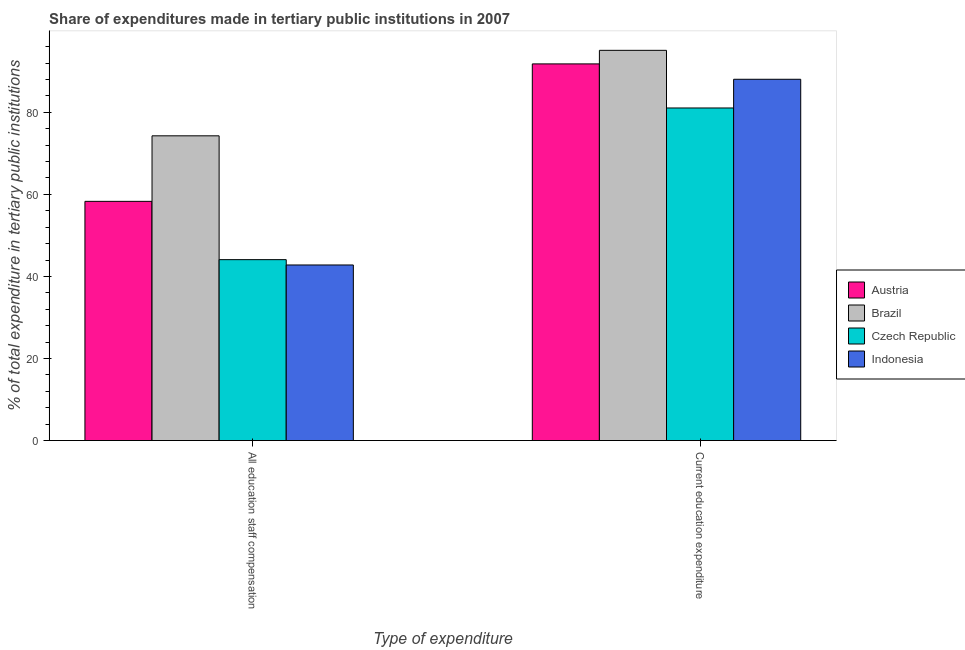Are the number of bars on each tick of the X-axis equal?
Make the answer very short. Yes. What is the label of the 2nd group of bars from the left?
Your answer should be compact. Current education expenditure. What is the expenditure in education in Indonesia?
Give a very brief answer. 88.04. Across all countries, what is the maximum expenditure in staff compensation?
Your answer should be very brief. 74.26. Across all countries, what is the minimum expenditure in education?
Your answer should be very brief. 81.05. In which country was the expenditure in education maximum?
Provide a succinct answer. Brazil. In which country was the expenditure in education minimum?
Make the answer very short. Czech Republic. What is the total expenditure in staff compensation in the graph?
Offer a terse response. 219.44. What is the difference between the expenditure in education in Czech Republic and that in Indonesia?
Keep it short and to the point. -7. What is the difference between the expenditure in education in Indonesia and the expenditure in staff compensation in Czech Republic?
Give a very brief answer. 43.96. What is the average expenditure in staff compensation per country?
Your answer should be very brief. 54.86. What is the difference between the expenditure in staff compensation and expenditure in education in Czech Republic?
Your answer should be very brief. -36.96. What is the ratio of the expenditure in staff compensation in Austria to that in Czech Republic?
Give a very brief answer. 1.32. What does the 4th bar from the left in All education staff compensation represents?
Your answer should be very brief. Indonesia. How many bars are there?
Your answer should be compact. 8. Are all the bars in the graph horizontal?
Your answer should be very brief. No. How many countries are there in the graph?
Make the answer very short. 4. Does the graph contain any zero values?
Provide a succinct answer. No. How many legend labels are there?
Provide a short and direct response. 4. What is the title of the graph?
Your answer should be very brief. Share of expenditures made in tertiary public institutions in 2007. Does "Least developed countries" appear as one of the legend labels in the graph?
Ensure brevity in your answer.  No. What is the label or title of the X-axis?
Offer a very short reply. Type of expenditure. What is the label or title of the Y-axis?
Give a very brief answer. % of total expenditure in tertiary public institutions. What is the % of total expenditure in tertiary public institutions of Austria in All education staff compensation?
Provide a short and direct response. 58.29. What is the % of total expenditure in tertiary public institutions in Brazil in All education staff compensation?
Keep it short and to the point. 74.26. What is the % of total expenditure in tertiary public institutions of Czech Republic in All education staff compensation?
Your answer should be compact. 44.09. What is the % of total expenditure in tertiary public institutions of Indonesia in All education staff compensation?
Your answer should be very brief. 42.79. What is the % of total expenditure in tertiary public institutions in Austria in Current education expenditure?
Offer a very short reply. 91.79. What is the % of total expenditure in tertiary public institutions in Brazil in Current education expenditure?
Offer a terse response. 95.09. What is the % of total expenditure in tertiary public institutions of Czech Republic in Current education expenditure?
Ensure brevity in your answer.  81.05. What is the % of total expenditure in tertiary public institutions in Indonesia in Current education expenditure?
Your answer should be very brief. 88.04. Across all Type of expenditure, what is the maximum % of total expenditure in tertiary public institutions in Austria?
Provide a succinct answer. 91.79. Across all Type of expenditure, what is the maximum % of total expenditure in tertiary public institutions in Brazil?
Your answer should be very brief. 95.09. Across all Type of expenditure, what is the maximum % of total expenditure in tertiary public institutions of Czech Republic?
Provide a succinct answer. 81.05. Across all Type of expenditure, what is the maximum % of total expenditure in tertiary public institutions in Indonesia?
Provide a short and direct response. 88.04. Across all Type of expenditure, what is the minimum % of total expenditure in tertiary public institutions in Austria?
Make the answer very short. 58.29. Across all Type of expenditure, what is the minimum % of total expenditure in tertiary public institutions in Brazil?
Your response must be concise. 74.26. Across all Type of expenditure, what is the minimum % of total expenditure in tertiary public institutions in Czech Republic?
Your answer should be very brief. 44.09. Across all Type of expenditure, what is the minimum % of total expenditure in tertiary public institutions of Indonesia?
Give a very brief answer. 42.79. What is the total % of total expenditure in tertiary public institutions in Austria in the graph?
Your answer should be very brief. 150.08. What is the total % of total expenditure in tertiary public institutions of Brazil in the graph?
Give a very brief answer. 169.36. What is the total % of total expenditure in tertiary public institutions of Czech Republic in the graph?
Offer a terse response. 125.14. What is the total % of total expenditure in tertiary public institutions of Indonesia in the graph?
Your answer should be very brief. 130.83. What is the difference between the % of total expenditure in tertiary public institutions of Austria in All education staff compensation and that in Current education expenditure?
Your response must be concise. -33.49. What is the difference between the % of total expenditure in tertiary public institutions of Brazil in All education staff compensation and that in Current education expenditure?
Give a very brief answer. -20.83. What is the difference between the % of total expenditure in tertiary public institutions of Czech Republic in All education staff compensation and that in Current education expenditure?
Ensure brevity in your answer.  -36.96. What is the difference between the % of total expenditure in tertiary public institutions in Indonesia in All education staff compensation and that in Current education expenditure?
Provide a short and direct response. -45.25. What is the difference between the % of total expenditure in tertiary public institutions in Austria in All education staff compensation and the % of total expenditure in tertiary public institutions in Brazil in Current education expenditure?
Make the answer very short. -36.8. What is the difference between the % of total expenditure in tertiary public institutions in Austria in All education staff compensation and the % of total expenditure in tertiary public institutions in Czech Republic in Current education expenditure?
Your response must be concise. -22.75. What is the difference between the % of total expenditure in tertiary public institutions of Austria in All education staff compensation and the % of total expenditure in tertiary public institutions of Indonesia in Current education expenditure?
Offer a terse response. -29.75. What is the difference between the % of total expenditure in tertiary public institutions in Brazil in All education staff compensation and the % of total expenditure in tertiary public institutions in Czech Republic in Current education expenditure?
Your response must be concise. -6.78. What is the difference between the % of total expenditure in tertiary public institutions of Brazil in All education staff compensation and the % of total expenditure in tertiary public institutions of Indonesia in Current education expenditure?
Your response must be concise. -13.78. What is the difference between the % of total expenditure in tertiary public institutions of Czech Republic in All education staff compensation and the % of total expenditure in tertiary public institutions of Indonesia in Current education expenditure?
Provide a succinct answer. -43.96. What is the average % of total expenditure in tertiary public institutions in Austria per Type of expenditure?
Your response must be concise. 75.04. What is the average % of total expenditure in tertiary public institutions of Brazil per Type of expenditure?
Your answer should be very brief. 84.68. What is the average % of total expenditure in tertiary public institutions in Czech Republic per Type of expenditure?
Your answer should be very brief. 62.57. What is the average % of total expenditure in tertiary public institutions of Indonesia per Type of expenditure?
Offer a terse response. 65.42. What is the difference between the % of total expenditure in tertiary public institutions in Austria and % of total expenditure in tertiary public institutions in Brazil in All education staff compensation?
Your answer should be very brief. -15.97. What is the difference between the % of total expenditure in tertiary public institutions of Austria and % of total expenditure in tertiary public institutions of Czech Republic in All education staff compensation?
Offer a very short reply. 14.21. What is the difference between the % of total expenditure in tertiary public institutions in Austria and % of total expenditure in tertiary public institutions in Indonesia in All education staff compensation?
Your answer should be compact. 15.5. What is the difference between the % of total expenditure in tertiary public institutions in Brazil and % of total expenditure in tertiary public institutions in Czech Republic in All education staff compensation?
Give a very brief answer. 30.18. What is the difference between the % of total expenditure in tertiary public institutions in Brazil and % of total expenditure in tertiary public institutions in Indonesia in All education staff compensation?
Offer a very short reply. 31.47. What is the difference between the % of total expenditure in tertiary public institutions of Czech Republic and % of total expenditure in tertiary public institutions of Indonesia in All education staff compensation?
Your response must be concise. 1.3. What is the difference between the % of total expenditure in tertiary public institutions of Austria and % of total expenditure in tertiary public institutions of Brazil in Current education expenditure?
Keep it short and to the point. -3.31. What is the difference between the % of total expenditure in tertiary public institutions in Austria and % of total expenditure in tertiary public institutions in Czech Republic in Current education expenditure?
Make the answer very short. 10.74. What is the difference between the % of total expenditure in tertiary public institutions of Austria and % of total expenditure in tertiary public institutions of Indonesia in Current education expenditure?
Your answer should be very brief. 3.74. What is the difference between the % of total expenditure in tertiary public institutions of Brazil and % of total expenditure in tertiary public institutions of Czech Republic in Current education expenditure?
Your response must be concise. 14.05. What is the difference between the % of total expenditure in tertiary public institutions in Brazil and % of total expenditure in tertiary public institutions in Indonesia in Current education expenditure?
Make the answer very short. 7.05. What is the difference between the % of total expenditure in tertiary public institutions of Czech Republic and % of total expenditure in tertiary public institutions of Indonesia in Current education expenditure?
Offer a very short reply. -7. What is the ratio of the % of total expenditure in tertiary public institutions of Austria in All education staff compensation to that in Current education expenditure?
Provide a succinct answer. 0.64. What is the ratio of the % of total expenditure in tertiary public institutions in Brazil in All education staff compensation to that in Current education expenditure?
Give a very brief answer. 0.78. What is the ratio of the % of total expenditure in tertiary public institutions of Czech Republic in All education staff compensation to that in Current education expenditure?
Give a very brief answer. 0.54. What is the ratio of the % of total expenditure in tertiary public institutions of Indonesia in All education staff compensation to that in Current education expenditure?
Offer a very short reply. 0.49. What is the difference between the highest and the second highest % of total expenditure in tertiary public institutions in Austria?
Provide a short and direct response. 33.49. What is the difference between the highest and the second highest % of total expenditure in tertiary public institutions in Brazil?
Your answer should be compact. 20.83. What is the difference between the highest and the second highest % of total expenditure in tertiary public institutions in Czech Republic?
Offer a terse response. 36.96. What is the difference between the highest and the second highest % of total expenditure in tertiary public institutions of Indonesia?
Your answer should be compact. 45.25. What is the difference between the highest and the lowest % of total expenditure in tertiary public institutions of Austria?
Your answer should be compact. 33.49. What is the difference between the highest and the lowest % of total expenditure in tertiary public institutions in Brazil?
Give a very brief answer. 20.83. What is the difference between the highest and the lowest % of total expenditure in tertiary public institutions in Czech Republic?
Make the answer very short. 36.96. What is the difference between the highest and the lowest % of total expenditure in tertiary public institutions in Indonesia?
Your response must be concise. 45.25. 